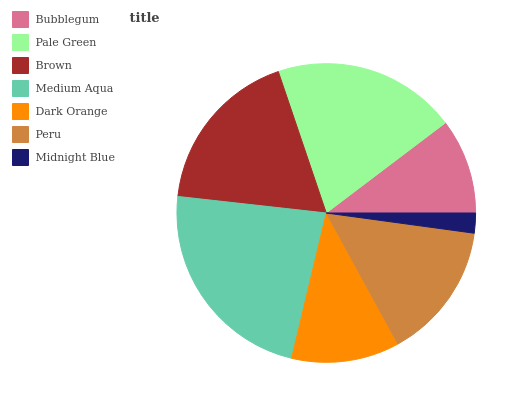Is Midnight Blue the minimum?
Answer yes or no. Yes. Is Medium Aqua the maximum?
Answer yes or no. Yes. Is Pale Green the minimum?
Answer yes or no. No. Is Pale Green the maximum?
Answer yes or no. No. Is Pale Green greater than Bubblegum?
Answer yes or no. Yes. Is Bubblegum less than Pale Green?
Answer yes or no. Yes. Is Bubblegum greater than Pale Green?
Answer yes or no. No. Is Pale Green less than Bubblegum?
Answer yes or no. No. Is Peru the high median?
Answer yes or no. Yes. Is Peru the low median?
Answer yes or no. Yes. Is Midnight Blue the high median?
Answer yes or no. No. Is Brown the low median?
Answer yes or no. No. 